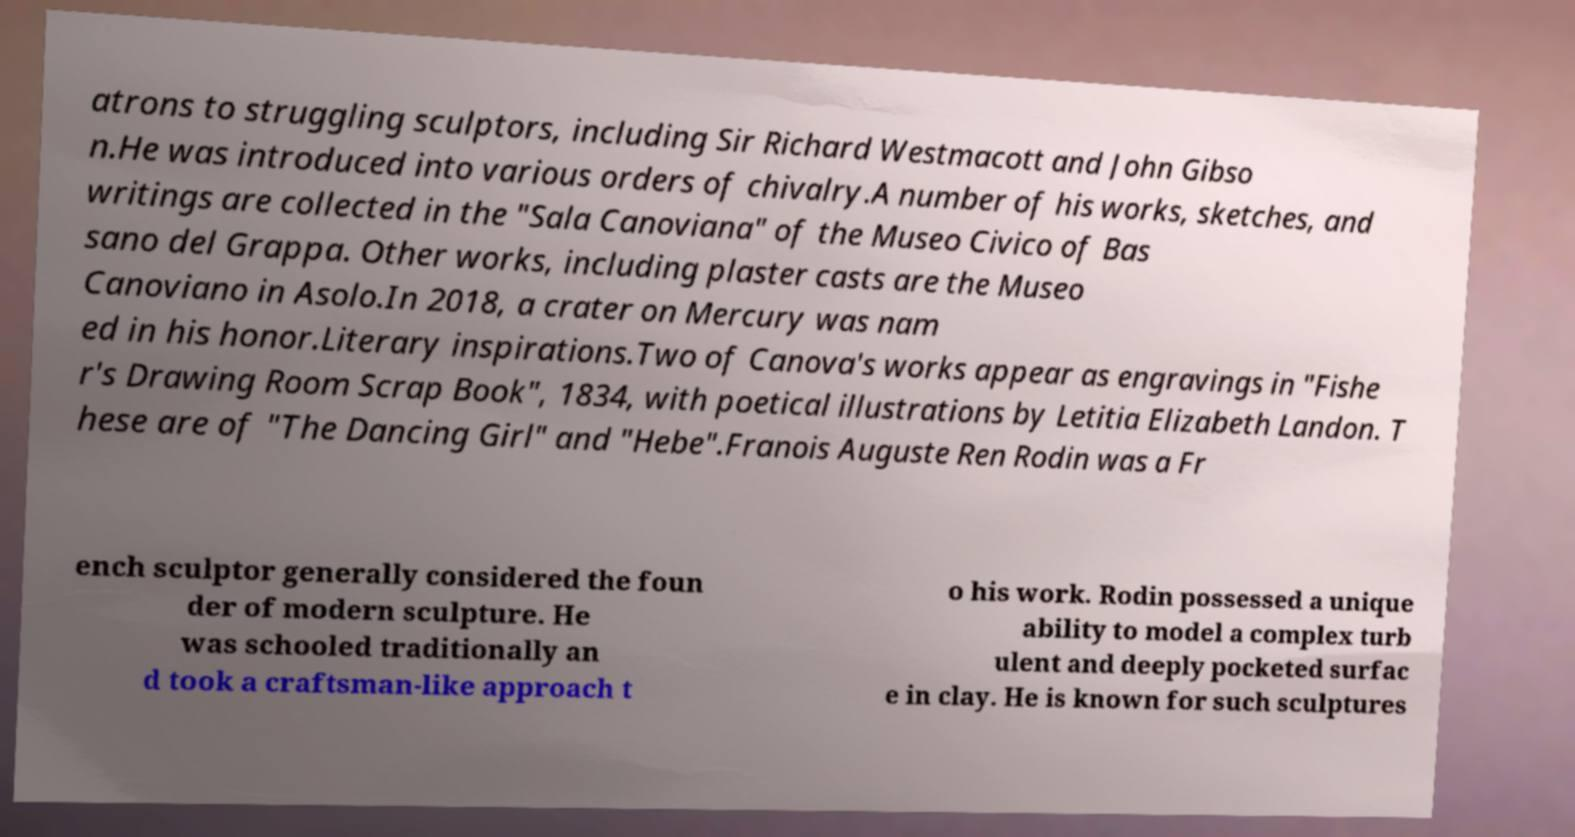For documentation purposes, I need the text within this image transcribed. Could you provide that? atrons to struggling sculptors, including Sir Richard Westmacott and John Gibso n.He was introduced into various orders of chivalry.A number of his works, sketches, and writings are collected in the "Sala Canoviana" of the Museo Civico of Bas sano del Grappa. Other works, including plaster casts are the Museo Canoviano in Asolo.In 2018, a crater on Mercury was nam ed in his honor.Literary inspirations.Two of Canova's works appear as engravings in "Fishe r's Drawing Room Scrap Book", 1834, with poetical illustrations by Letitia Elizabeth Landon. T hese are of "The Dancing Girl" and "Hebe".Franois Auguste Ren Rodin was a Fr ench sculptor generally considered the foun der of modern sculpture. He was schooled traditionally an d took a craftsman-like approach t o his work. Rodin possessed a unique ability to model a complex turb ulent and deeply pocketed surfac e in clay. He is known for such sculptures 